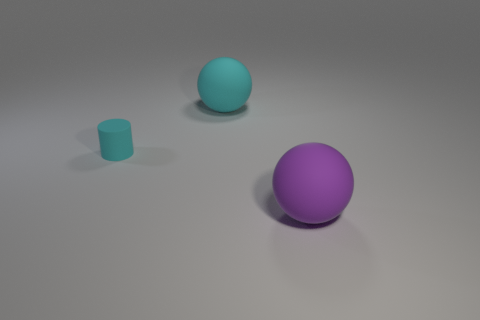Add 2 matte balls. How many objects exist? 5 Subtract all cylinders. How many objects are left? 2 Subtract 0 red cubes. How many objects are left? 3 Subtract all tiny matte things. Subtract all small cylinders. How many objects are left? 1 Add 3 big balls. How many big balls are left? 5 Add 3 purple balls. How many purple balls exist? 4 